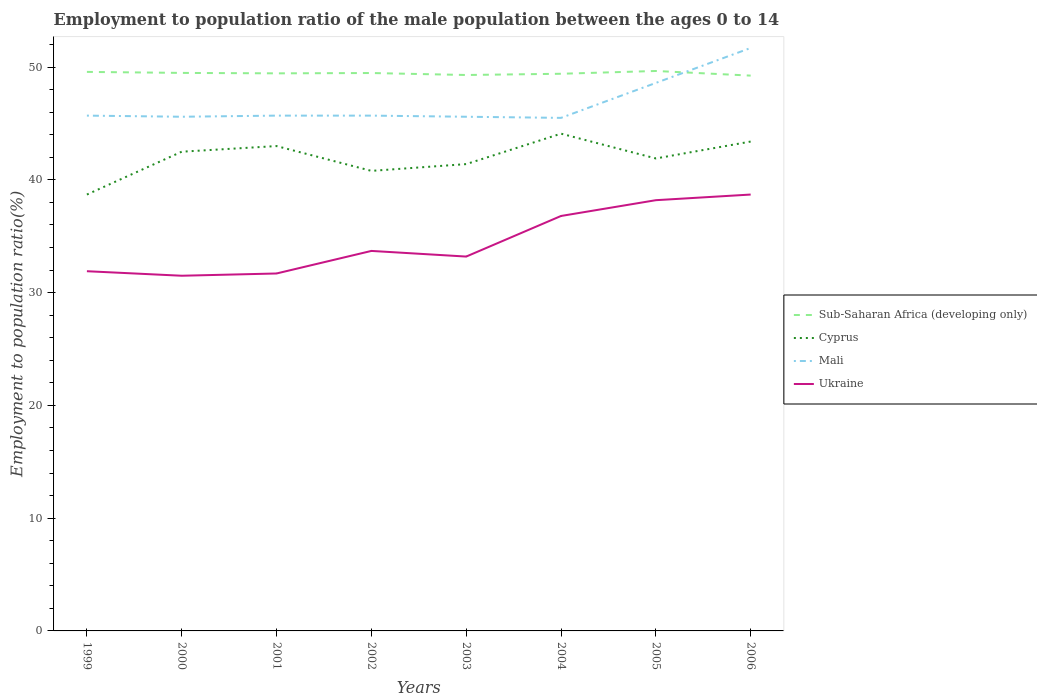Does the line corresponding to Mali intersect with the line corresponding to Cyprus?
Provide a short and direct response. No. Is the number of lines equal to the number of legend labels?
Your answer should be very brief. Yes. Across all years, what is the maximum employment to population ratio in Sub-Saharan Africa (developing only)?
Keep it short and to the point. 49.25. In which year was the employment to population ratio in Mali maximum?
Offer a very short reply. 2004. What is the difference between the highest and the second highest employment to population ratio in Ukraine?
Your response must be concise. 7.2. What is the difference between the highest and the lowest employment to population ratio in Ukraine?
Ensure brevity in your answer.  3. Is the employment to population ratio in Ukraine strictly greater than the employment to population ratio in Mali over the years?
Keep it short and to the point. Yes. Does the graph contain grids?
Keep it short and to the point. No. How are the legend labels stacked?
Offer a terse response. Vertical. What is the title of the graph?
Your response must be concise. Employment to population ratio of the male population between the ages 0 to 14. What is the label or title of the X-axis?
Provide a short and direct response. Years. What is the label or title of the Y-axis?
Offer a terse response. Employment to population ratio(%). What is the Employment to population ratio(%) of Sub-Saharan Africa (developing only) in 1999?
Your answer should be very brief. 49.58. What is the Employment to population ratio(%) in Cyprus in 1999?
Offer a very short reply. 38.7. What is the Employment to population ratio(%) of Mali in 1999?
Give a very brief answer. 45.7. What is the Employment to population ratio(%) of Ukraine in 1999?
Your response must be concise. 31.9. What is the Employment to population ratio(%) in Sub-Saharan Africa (developing only) in 2000?
Ensure brevity in your answer.  49.49. What is the Employment to population ratio(%) of Cyprus in 2000?
Your response must be concise. 42.5. What is the Employment to population ratio(%) of Mali in 2000?
Offer a terse response. 45.6. What is the Employment to population ratio(%) in Ukraine in 2000?
Make the answer very short. 31.5. What is the Employment to population ratio(%) of Sub-Saharan Africa (developing only) in 2001?
Offer a terse response. 49.45. What is the Employment to population ratio(%) of Mali in 2001?
Your response must be concise. 45.7. What is the Employment to population ratio(%) of Ukraine in 2001?
Your response must be concise. 31.7. What is the Employment to population ratio(%) in Sub-Saharan Africa (developing only) in 2002?
Your answer should be very brief. 49.48. What is the Employment to population ratio(%) in Cyprus in 2002?
Your response must be concise. 40.8. What is the Employment to population ratio(%) of Mali in 2002?
Your answer should be compact. 45.7. What is the Employment to population ratio(%) in Ukraine in 2002?
Your answer should be very brief. 33.7. What is the Employment to population ratio(%) of Sub-Saharan Africa (developing only) in 2003?
Your answer should be compact. 49.3. What is the Employment to population ratio(%) of Cyprus in 2003?
Offer a terse response. 41.4. What is the Employment to population ratio(%) of Mali in 2003?
Make the answer very short. 45.6. What is the Employment to population ratio(%) of Ukraine in 2003?
Your response must be concise. 33.2. What is the Employment to population ratio(%) of Sub-Saharan Africa (developing only) in 2004?
Make the answer very short. 49.41. What is the Employment to population ratio(%) in Cyprus in 2004?
Your response must be concise. 44.1. What is the Employment to population ratio(%) in Mali in 2004?
Your response must be concise. 45.5. What is the Employment to population ratio(%) in Ukraine in 2004?
Offer a terse response. 36.8. What is the Employment to population ratio(%) in Sub-Saharan Africa (developing only) in 2005?
Your answer should be very brief. 49.66. What is the Employment to population ratio(%) of Cyprus in 2005?
Provide a succinct answer. 41.9. What is the Employment to population ratio(%) of Mali in 2005?
Your response must be concise. 48.6. What is the Employment to population ratio(%) of Ukraine in 2005?
Your answer should be compact. 38.2. What is the Employment to population ratio(%) in Sub-Saharan Africa (developing only) in 2006?
Offer a very short reply. 49.25. What is the Employment to population ratio(%) in Cyprus in 2006?
Your response must be concise. 43.4. What is the Employment to population ratio(%) in Mali in 2006?
Keep it short and to the point. 51.7. What is the Employment to population ratio(%) of Ukraine in 2006?
Keep it short and to the point. 38.7. Across all years, what is the maximum Employment to population ratio(%) in Sub-Saharan Africa (developing only)?
Your answer should be very brief. 49.66. Across all years, what is the maximum Employment to population ratio(%) of Cyprus?
Your answer should be compact. 44.1. Across all years, what is the maximum Employment to population ratio(%) of Mali?
Provide a succinct answer. 51.7. Across all years, what is the maximum Employment to population ratio(%) of Ukraine?
Keep it short and to the point. 38.7. Across all years, what is the minimum Employment to population ratio(%) of Sub-Saharan Africa (developing only)?
Your answer should be compact. 49.25. Across all years, what is the minimum Employment to population ratio(%) of Cyprus?
Your answer should be compact. 38.7. Across all years, what is the minimum Employment to population ratio(%) of Mali?
Give a very brief answer. 45.5. Across all years, what is the minimum Employment to population ratio(%) of Ukraine?
Provide a succinct answer. 31.5. What is the total Employment to population ratio(%) of Sub-Saharan Africa (developing only) in the graph?
Make the answer very short. 395.61. What is the total Employment to population ratio(%) of Cyprus in the graph?
Give a very brief answer. 335.8. What is the total Employment to population ratio(%) of Mali in the graph?
Your answer should be very brief. 374.1. What is the total Employment to population ratio(%) in Ukraine in the graph?
Offer a terse response. 275.7. What is the difference between the Employment to population ratio(%) of Sub-Saharan Africa (developing only) in 1999 and that in 2000?
Provide a succinct answer. 0.09. What is the difference between the Employment to population ratio(%) in Ukraine in 1999 and that in 2000?
Provide a short and direct response. 0.4. What is the difference between the Employment to population ratio(%) in Sub-Saharan Africa (developing only) in 1999 and that in 2001?
Provide a short and direct response. 0.13. What is the difference between the Employment to population ratio(%) in Ukraine in 1999 and that in 2001?
Your response must be concise. 0.2. What is the difference between the Employment to population ratio(%) of Sub-Saharan Africa (developing only) in 1999 and that in 2002?
Make the answer very short. 0.1. What is the difference between the Employment to population ratio(%) in Cyprus in 1999 and that in 2002?
Keep it short and to the point. -2.1. What is the difference between the Employment to population ratio(%) of Mali in 1999 and that in 2002?
Provide a succinct answer. 0. What is the difference between the Employment to population ratio(%) of Sub-Saharan Africa (developing only) in 1999 and that in 2003?
Offer a terse response. 0.28. What is the difference between the Employment to population ratio(%) of Cyprus in 1999 and that in 2003?
Ensure brevity in your answer.  -2.7. What is the difference between the Employment to population ratio(%) in Mali in 1999 and that in 2003?
Your answer should be compact. 0.1. What is the difference between the Employment to population ratio(%) of Ukraine in 1999 and that in 2003?
Offer a very short reply. -1.3. What is the difference between the Employment to population ratio(%) of Sub-Saharan Africa (developing only) in 1999 and that in 2004?
Your answer should be compact. 0.17. What is the difference between the Employment to population ratio(%) in Ukraine in 1999 and that in 2004?
Your answer should be very brief. -4.9. What is the difference between the Employment to population ratio(%) in Sub-Saharan Africa (developing only) in 1999 and that in 2005?
Keep it short and to the point. -0.08. What is the difference between the Employment to population ratio(%) of Sub-Saharan Africa (developing only) in 1999 and that in 2006?
Your answer should be very brief. 0.33. What is the difference between the Employment to population ratio(%) in Ukraine in 1999 and that in 2006?
Keep it short and to the point. -6.8. What is the difference between the Employment to population ratio(%) in Sub-Saharan Africa (developing only) in 2000 and that in 2001?
Your answer should be compact. 0.04. What is the difference between the Employment to population ratio(%) in Cyprus in 2000 and that in 2001?
Keep it short and to the point. -0.5. What is the difference between the Employment to population ratio(%) of Mali in 2000 and that in 2001?
Ensure brevity in your answer.  -0.1. What is the difference between the Employment to population ratio(%) in Sub-Saharan Africa (developing only) in 2000 and that in 2002?
Make the answer very short. 0.01. What is the difference between the Employment to population ratio(%) in Cyprus in 2000 and that in 2002?
Provide a short and direct response. 1.7. What is the difference between the Employment to population ratio(%) of Mali in 2000 and that in 2002?
Your response must be concise. -0.1. What is the difference between the Employment to population ratio(%) of Ukraine in 2000 and that in 2002?
Provide a short and direct response. -2.2. What is the difference between the Employment to population ratio(%) in Sub-Saharan Africa (developing only) in 2000 and that in 2003?
Ensure brevity in your answer.  0.19. What is the difference between the Employment to population ratio(%) in Cyprus in 2000 and that in 2003?
Keep it short and to the point. 1.1. What is the difference between the Employment to population ratio(%) in Sub-Saharan Africa (developing only) in 2000 and that in 2004?
Offer a terse response. 0.08. What is the difference between the Employment to population ratio(%) in Ukraine in 2000 and that in 2004?
Provide a short and direct response. -5.3. What is the difference between the Employment to population ratio(%) of Sub-Saharan Africa (developing only) in 2000 and that in 2005?
Make the answer very short. -0.17. What is the difference between the Employment to population ratio(%) in Cyprus in 2000 and that in 2005?
Make the answer very short. 0.6. What is the difference between the Employment to population ratio(%) of Mali in 2000 and that in 2005?
Your answer should be compact. -3. What is the difference between the Employment to population ratio(%) of Sub-Saharan Africa (developing only) in 2000 and that in 2006?
Ensure brevity in your answer.  0.24. What is the difference between the Employment to population ratio(%) in Ukraine in 2000 and that in 2006?
Your response must be concise. -7.2. What is the difference between the Employment to population ratio(%) in Sub-Saharan Africa (developing only) in 2001 and that in 2002?
Offer a very short reply. -0.03. What is the difference between the Employment to population ratio(%) of Cyprus in 2001 and that in 2002?
Keep it short and to the point. 2.2. What is the difference between the Employment to population ratio(%) of Sub-Saharan Africa (developing only) in 2001 and that in 2003?
Ensure brevity in your answer.  0.15. What is the difference between the Employment to population ratio(%) of Ukraine in 2001 and that in 2003?
Provide a short and direct response. -1.5. What is the difference between the Employment to population ratio(%) of Sub-Saharan Africa (developing only) in 2001 and that in 2004?
Ensure brevity in your answer.  0.04. What is the difference between the Employment to population ratio(%) of Cyprus in 2001 and that in 2004?
Your answer should be very brief. -1.1. What is the difference between the Employment to population ratio(%) of Mali in 2001 and that in 2004?
Your response must be concise. 0.2. What is the difference between the Employment to population ratio(%) in Ukraine in 2001 and that in 2004?
Give a very brief answer. -5.1. What is the difference between the Employment to population ratio(%) in Sub-Saharan Africa (developing only) in 2001 and that in 2005?
Give a very brief answer. -0.21. What is the difference between the Employment to population ratio(%) in Mali in 2001 and that in 2005?
Offer a terse response. -2.9. What is the difference between the Employment to population ratio(%) of Sub-Saharan Africa (developing only) in 2001 and that in 2006?
Offer a very short reply. 0.2. What is the difference between the Employment to population ratio(%) in Cyprus in 2001 and that in 2006?
Your response must be concise. -0.4. What is the difference between the Employment to population ratio(%) of Mali in 2001 and that in 2006?
Offer a very short reply. -6. What is the difference between the Employment to population ratio(%) in Ukraine in 2001 and that in 2006?
Ensure brevity in your answer.  -7. What is the difference between the Employment to population ratio(%) of Sub-Saharan Africa (developing only) in 2002 and that in 2003?
Your response must be concise. 0.18. What is the difference between the Employment to population ratio(%) of Cyprus in 2002 and that in 2003?
Keep it short and to the point. -0.6. What is the difference between the Employment to population ratio(%) in Ukraine in 2002 and that in 2003?
Provide a succinct answer. 0.5. What is the difference between the Employment to population ratio(%) of Sub-Saharan Africa (developing only) in 2002 and that in 2004?
Provide a short and direct response. 0.07. What is the difference between the Employment to population ratio(%) in Cyprus in 2002 and that in 2004?
Offer a terse response. -3.3. What is the difference between the Employment to population ratio(%) in Mali in 2002 and that in 2004?
Your response must be concise. 0.2. What is the difference between the Employment to population ratio(%) of Sub-Saharan Africa (developing only) in 2002 and that in 2005?
Keep it short and to the point. -0.18. What is the difference between the Employment to population ratio(%) in Ukraine in 2002 and that in 2005?
Provide a succinct answer. -4.5. What is the difference between the Employment to population ratio(%) in Sub-Saharan Africa (developing only) in 2002 and that in 2006?
Your response must be concise. 0.23. What is the difference between the Employment to population ratio(%) in Mali in 2002 and that in 2006?
Your answer should be very brief. -6. What is the difference between the Employment to population ratio(%) of Sub-Saharan Africa (developing only) in 2003 and that in 2004?
Make the answer very short. -0.11. What is the difference between the Employment to population ratio(%) in Cyprus in 2003 and that in 2004?
Offer a very short reply. -2.7. What is the difference between the Employment to population ratio(%) of Sub-Saharan Africa (developing only) in 2003 and that in 2005?
Make the answer very short. -0.36. What is the difference between the Employment to population ratio(%) of Mali in 2003 and that in 2005?
Offer a very short reply. -3. What is the difference between the Employment to population ratio(%) of Ukraine in 2003 and that in 2005?
Provide a short and direct response. -5. What is the difference between the Employment to population ratio(%) in Sub-Saharan Africa (developing only) in 2003 and that in 2006?
Your answer should be compact. 0.05. What is the difference between the Employment to population ratio(%) in Cyprus in 2003 and that in 2006?
Keep it short and to the point. -2. What is the difference between the Employment to population ratio(%) in Mali in 2003 and that in 2006?
Provide a succinct answer. -6.1. What is the difference between the Employment to population ratio(%) in Sub-Saharan Africa (developing only) in 2004 and that in 2005?
Your response must be concise. -0.25. What is the difference between the Employment to population ratio(%) in Cyprus in 2004 and that in 2005?
Offer a very short reply. 2.2. What is the difference between the Employment to population ratio(%) in Sub-Saharan Africa (developing only) in 2004 and that in 2006?
Make the answer very short. 0.16. What is the difference between the Employment to population ratio(%) of Cyprus in 2004 and that in 2006?
Your response must be concise. 0.7. What is the difference between the Employment to population ratio(%) in Mali in 2004 and that in 2006?
Provide a short and direct response. -6.2. What is the difference between the Employment to population ratio(%) in Sub-Saharan Africa (developing only) in 2005 and that in 2006?
Your answer should be compact. 0.41. What is the difference between the Employment to population ratio(%) of Cyprus in 2005 and that in 2006?
Your response must be concise. -1.5. What is the difference between the Employment to population ratio(%) of Mali in 2005 and that in 2006?
Your answer should be very brief. -3.1. What is the difference between the Employment to population ratio(%) in Ukraine in 2005 and that in 2006?
Your answer should be very brief. -0.5. What is the difference between the Employment to population ratio(%) in Sub-Saharan Africa (developing only) in 1999 and the Employment to population ratio(%) in Cyprus in 2000?
Give a very brief answer. 7.08. What is the difference between the Employment to population ratio(%) of Sub-Saharan Africa (developing only) in 1999 and the Employment to population ratio(%) of Mali in 2000?
Offer a terse response. 3.98. What is the difference between the Employment to population ratio(%) of Sub-Saharan Africa (developing only) in 1999 and the Employment to population ratio(%) of Ukraine in 2000?
Your answer should be very brief. 18.08. What is the difference between the Employment to population ratio(%) of Cyprus in 1999 and the Employment to population ratio(%) of Mali in 2000?
Ensure brevity in your answer.  -6.9. What is the difference between the Employment to population ratio(%) in Mali in 1999 and the Employment to population ratio(%) in Ukraine in 2000?
Provide a succinct answer. 14.2. What is the difference between the Employment to population ratio(%) in Sub-Saharan Africa (developing only) in 1999 and the Employment to population ratio(%) in Cyprus in 2001?
Keep it short and to the point. 6.58. What is the difference between the Employment to population ratio(%) in Sub-Saharan Africa (developing only) in 1999 and the Employment to population ratio(%) in Mali in 2001?
Give a very brief answer. 3.88. What is the difference between the Employment to population ratio(%) in Sub-Saharan Africa (developing only) in 1999 and the Employment to population ratio(%) in Ukraine in 2001?
Keep it short and to the point. 17.88. What is the difference between the Employment to population ratio(%) of Cyprus in 1999 and the Employment to population ratio(%) of Mali in 2001?
Your response must be concise. -7. What is the difference between the Employment to population ratio(%) of Cyprus in 1999 and the Employment to population ratio(%) of Ukraine in 2001?
Provide a short and direct response. 7. What is the difference between the Employment to population ratio(%) of Sub-Saharan Africa (developing only) in 1999 and the Employment to population ratio(%) of Cyprus in 2002?
Give a very brief answer. 8.78. What is the difference between the Employment to population ratio(%) of Sub-Saharan Africa (developing only) in 1999 and the Employment to population ratio(%) of Mali in 2002?
Your response must be concise. 3.88. What is the difference between the Employment to population ratio(%) of Sub-Saharan Africa (developing only) in 1999 and the Employment to population ratio(%) of Ukraine in 2002?
Your response must be concise. 15.88. What is the difference between the Employment to population ratio(%) of Cyprus in 1999 and the Employment to population ratio(%) of Ukraine in 2002?
Your answer should be compact. 5. What is the difference between the Employment to population ratio(%) in Mali in 1999 and the Employment to population ratio(%) in Ukraine in 2002?
Offer a very short reply. 12. What is the difference between the Employment to population ratio(%) of Sub-Saharan Africa (developing only) in 1999 and the Employment to population ratio(%) of Cyprus in 2003?
Your answer should be compact. 8.18. What is the difference between the Employment to population ratio(%) in Sub-Saharan Africa (developing only) in 1999 and the Employment to population ratio(%) in Mali in 2003?
Your response must be concise. 3.98. What is the difference between the Employment to population ratio(%) in Sub-Saharan Africa (developing only) in 1999 and the Employment to population ratio(%) in Ukraine in 2003?
Make the answer very short. 16.38. What is the difference between the Employment to population ratio(%) of Cyprus in 1999 and the Employment to population ratio(%) of Ukraine in 2003?
Give a very brief answer. 5.5. What is the difference between the Employment to population ratio(%) in Mali in 1999 and the Employment to population ratio(%) in Ukraine in 2003?
Your response must be concise. 12.5. What is the difference between the Employment to population ratio(%) in Sub-Saharan Africa (developing only) in 1999 and the Employment to population ratio(%) in Cyprus in 2004?
Provide a short and direct response. 5.48. What is the difference between the Employment to population ratio(%) of Sub-Saharan Africa (developing only) in 1999 and the Employment to population ratio(%) of Mali in 2004?
Your answer should be very brief. 4.08. What is the difference between the Employment to population ratio(%) in Sub-Saharan Africa (developing only) in 1999 and the Employment to population ratio(%) in Ukraine in 2004?
Offer a very short reply. 12.78. What is the difference between the Employment to population ratio(%) of Sub-Saharan Africa (developing only) in 1999 and the Employment to population ratio(%) of Cyprus in 2005?
Provide a succinct answer. 7.68. What is the difference between the Employment to population ratio(%) in Sub-Saharan Africa (developing only) in 1999 and the Employment to population ratio(%) in Mali in 2005?
Offer a very short reply. 0.98. What is the difference between the Employment to population ratio(%) of Sub-Saharan Africa (developing only) in 1999 and the Employment to population ratio(%) of Ukraine in 2005?
Offer a very short reply. 11.38. What is the difference between the Employment to population ratio(%) of Mali in 1999 and the Employment to population ratio(%) of Ukraine in 2005?
Ensure brevity in your answer.  7.5. What is the difference between the Employment to population ratio(%) in Sub-Saharan Africa (developing only) in 1999 and the Employment to population ratio(%) in Cyprus in 2006?
Offer a terse response. 6.18. What is the difference between the Employment to population ratio(%) of Sub-Saharan Africa (developing only) in 1999 and the Employment to population ratio(%) of Mali in 2006?
Make the answer very short. -2.12. What is the difference between the Employment to population ratio(%) in Sub-Saharan Africa (developing only) in 1999 and the Employment to population ratio(%) in Ukraine in 2006?
Provide a short and direct response. 10.88. What is the difference between the Employment to population ratio(%) of Mali in 1999 and the Employment to population ratio(%) of Ukraine in 2006?
Your response must be concise. 7. What is the difference between the Employment to population ratio(%) in Sub-Saharan Africa (developing only) in 2000 and the Employment to population ratio(%) in Cyprus in 2001?
Give a very brief answer. 6.49. What is the difference between the Employment to population ratio(%) of Sub-Saharan Africa (developing only) in 2000 and the Employment to population ratio(%) of Mali in 2001?
Keep it short and to the point. 3.79. What is the difference between the Employment to population ratio(%) of Sub-Saharan Africa (developing only) in 2000 and the Employment to population ratio(%) of Ukraine in 2001?
Ensure brevity in your answer.  17.79. What is the difference between the Employment to population ratio(%) of Cyprus in 2000 and the Employment to population ratio(%) of Mali in 2001?
Provide a succinct answer. -3.2. What is the difference between the Employment to population ratio(%) of Cyprus in 2000 and the Employment to population ratio(%) of Ukraine in 2001?
Your response must be concise. 10.8. What is the difference between the Employment to population ratio(%) of Sub-Saharan Africa (developing only) in 2000 and the Employment to population ratio(%) of Cyprus in 2002?
Keep it short and to the point. 8.69. What is the difference between the Employment to population ratio(%) of Sub-Saharan Africa (developing only) in 2000 and the Employment to population ratio(%) of Mali in 2002?
Your response must be concise. 3.79. What is the difference between the Employment to population ratio(%) of Sub-Saharan Africa (developing only) in 2000 and the Employment to population ratio(%) of Ukraine in 2002?
Your answer should be compact. 15.79. What is the difference between the Employment to population ratio(%) in Cyprus in 2000 and the Employment to population ratio(%) in Mali in 2002?
Your response must be concise. -3.2. What is the difference between the Employment to population ratio(%) in Cyprus in 2000 and the Employment to population ratio(%) in Ukraine in 2002?
Provide a succinct answer. 8.8. What is the difference between the Employment to population ratio(%) in Sub-Saharan Africa (developing only) in 2000 and the Employment to population ratio(%) in Cyprus in 2003?
Give a very brief answer. 8.09. What is the difference between the Employment to population ratio(%) in Sub-Saharan Africa (developing only) in 2000 and the Employment to population ratio(%) in Mali in 2003?
Make the answer very short. 3.89. What is the difference between the Employment to population ratio(%) of Sub-Saharan Africa (developing only) in 2000 and the Employment to population ratio(%) of Ukraine in 2003?
Offer a terse response. 16.29. What is the difference between the Employment to population ratio(%) of Cyprus in 2000 and the Employment to population ratio(%) of Mali in 2003?
Your answer should be compact. -3.1. What is the difference between the Employment to population ratio(%) in Cyprus in 2000 and the Employment to population ratio(%) in Ukraine in 2003?
Provide a succinct answer. 9.3. What is the difference between the Employment to population ratio(%) in Mali in 2000 and the Employment to population ratio(%) in Ukraine in 2003?
Your answer should be very brief. 12.4. What is the difference between the Employment to population ratio(%) of Sub-Saharan Africa (developing only) in 2000 and the Employment to population ratio(%) of Cyprus in 2004?
Your answer should be very brief. 5.39. What is the difference between the Employment to population ratio(%) of Sub-Saharan Africa (developing only) in 2000 and the Employment to population ratio(%) of Mali in 2004?
Provide a short and direct response. 3.99. What is the difference between the Employment to population ratio(%) of Sub-Saharan Africa (developing only) in 2000 and the Employment to population ratio(%) of Ukraine in 2004?
Provide a short and direct response. 12.69. What is the difference between the Employment to population ratio(%) in Cyprus in 2000 and the Employment to population ratio(%) in Ukraine in 2004?
Your answer should be very brief. 5.7. What is the difference between the Employment to population ratio(%) in Mali in 2000 and the Employment to population ratio(%) in Ukraine in 2004?
Give a very brief answer. 8.8. What is the difference between the Employment to population ratio(%) of Sub-Saharan Africa (developing only) in 2000 and the Employment to population ratio(%) of Cyprus in 2005?
Ensure brevity in your answer.  7.59. What is the difference between the Employment to population ratio(%) in Sub-Saharan Africa (developing only) in 2000 and the Employment to population ratio(%) in Mali in 2005?
Offer a terse response. 0.89. What is the difference between the Employment to population ratio(%) of Sub-Saharan Africa (developing only) in 2000 and the Employment to population ratio(%) of Ukraine in 2005?
Offer a terse response. 11.29. What is the difference between the Employment to population ratio(%) of Sub-Saharan Africa (developing only) in 2000 and the Employment to population ratio(%) of Cyprus in 2006?
Ensure brevity in your answer.  6.09. What is the difference between the Employment to population ratio(%) of Sub-Saharan Africa (developing only) in 2000 and the Employment to population ratio(%) of Mali in 2006?
Provide a short and direct response. -2.21. What is the difference between the Employment to population ratio(%) in Sub-Saharan Africa (developing only) in 2000 and the Employment to population ratio(%) in Ukraine in 2006?
Ensure brevity in your answer.  10.79. What is the difference between the Employment to population ratio(%) in Mali in 2000 and the Employment to population ratio(%) in Ukraine in 2006?
Your answer should be very brief. 6.9. What is the difference between the Employment to population ratio(%) of Sub-Saharan Africa (developing only) in 2001 and the Employment to population ratio(%) of Cyprus in 2002?
Give a very brief answer. 8.65. What is the difference between the Employment to population ratio(%) of Sub-Saharan Africa (developing only) in 2001 and the Employment to population ratio(%) of Mali in 2002?
Offer a terse response. 3.75. What is the difference between the Employment to population ratio(%) of Sub-Saharan Africa (developing only) in 2001 and the Employment to population ratio(%) of Ukraine in 2002?
Ensure brevity in your answer.  15.75. What is the difference between the Employment to population ratio(%) in Sub-Saharan Africa (developing only) in 2001 and the Employment to population ratio(%) in Cyprus in 2003?
Make the answer very short. 8.05. What is the difference between the Employment to population ratio(%) of Sub-Saharan Africa (developing only) in 2001 and the Employment to population ratio(%) of Mali in 2003?
Keep it short and to the point. 3.85. What is the difference between the Employment to population ratio(%) of Sub-Saharan Africa (developing only) in 2001 and the Employment to population ratio(%) of Ukraine in 2003?
Give a very brief answer. 16.25. What is the difference between the Employment to population ratio(%) in Cyprus in 2001 and the Employment to population ratio(%) in Mali in 2003?
Provide a succinct answer. -2.6. What is the difference between the Employment to population ratio(%) in Sub-Saharan Africa (developing only) in 2001 and the Employment to population ratio(%) in Cyprus in 2004?
Make the answer very short. 5.35. What is the difference between the Employment to population ratio(%) of Sub-Saharan Africa (developing only) in 2001 and the Employment to population ratio(%) of Mali in 2004?
Offer a terse response. 3.95. What is the difference between the Employment to population ratio(%) in Sub-Saharan Africa (developing only) in 2001 and the Employment to population ratio(%) in Ukraine in 2004?
Your response must be concise. 12.65. What is the difference between the Employment to population ratio(%) of Cyprus in 2001 and the Employment to population ratio(%) of Ukraine in 2004?
Offer a very short reply. 6.2. What is the difference between the Employment to population ratio(%) of Sub-Saharan Africa (developing only) in 2001 and the Employment to population ratio(%) of Cyprus in 2005?
Offer a very short reply. 7.55. What is the difference between the Employment to population ratio(%) of Sub-Saharan Africa (developing only) in 2001 and the Employment to population ratio(%) of Mali in 2005?
Your answer should be very brief. 0.85. What is the difference between the Employment to population ratio(%) of Sub-Saharan Africa (developing only) in 2001 and the Employment to population ratio(%) of Ukraine in 2005?
Ensure brevity in your answer.  11.25. What is the difference between the Employment to population ratio(%) in Sub-Saharan Africa (developing only) in 2001 and the Employment to population ratio(%) in Cyprus in 2006?
Provide a succinct answer. 6.05. What is the difference between the Employment to population ratio(%) in Sub-Saharan Africa (developing only) in 2001 and the Employment to population ratio(%) in Mali in 2006?
Offer a very short reply. -2.25. What is the difference between the Employment to population ratio(%) of Sub-Saharan Africa (developing only) in 2001 and the Employment to population ratio(%) of Ukraine in 2006?
Your response must be concise. 10.75. What is the difference between the Employment to population ratio(%) in Cyprus in 2001 and the Employment to population ratio(%) in Mali in 2006?
Your answer should be very brief. -8.7. What is the difference between the Employment to population ratio(%) of Mali in 2001 and the Employment to population ratio(%) of Ukraine in 2006?
Your response must be concise. 7. What is the difference between the Employment to population ratio(%) of Sub-Saharan Africa (developing only) in 2002 and the Employment to population ratio(%) of Cyprus in 2003?
Keep it short and to the point. 8.08. What is the difference between the Employment to population ratio(%) of Sub-Saharan Africa (developing only) in 2002 and the Employment to population ratio(%) of Mali in 2003?
Ensure brevity in your answer.  3.88. What is the difference between the Employment to population ratio(%) in Sub-Saharan Africa (developing only) in 2002 and the Employment to population ratio(%) in Ukraine in 2003?
Your response must be concise. 16.28. What is the difference between the Employment to population ratio(%) of Cyprus in 2002 and the Employment to population ratio(%) of Mali in 2003?
Ensure brevity in your answer.  -4.8. What is the difference between the Employment to population ratio(%) of Mali in 2002 and the Employment to population ratio(%) of Ukraine in 2003?
Offer a terse response. 12.5. What is the difference between the Employment to population ratio(%) in Sub-Saharan Africa (developing only) in 2002 and the Employment to population ratio(%) in Cyprus in 2004?
Offer a terse response. 5.38. What is the difference between the Employment to population ratio(%) in Sub-Saharan Africa (developing only) in 2002 and the Employment to population ratio(%) in Mali in 2004?
Your answer should be very brief. 3.98. What is the difference between the Employment to population ratio(%) in Sub-Saharan Africa (developing only) in 2002 and the Employment to population ratio(%) in Ukraine in 2004?
Your response must be concise. 12.68. What is the difference between the Employment to population ratio(%) in Cyprus in 2002 and the Employment to population ratio(%) in Mali in 2004?
Provide a succinct answer. -4.7. What is the difference between the Employment to population ratio(%) of Cyprus in 2002 and the Employment to population ratio(%) of Ukraine in 2004?
Your response must be concise. 4. What is the difference between the Employment to population ratio(%) of Sub-Saharan Africa (developing only) in 2002 and the Employment to population ratio(%) of Cyprus in 2005?
Provide a short and direct response. 7.58. What is the difference between the Employment to population ratio(%) of Sub-Saharan Africa (developing only) in 2002 and the Employment to population ratio(%) of Mali in 2005?
Keep it short and to the point. 0.88. What is the difference between the Employment to population ratio(%) in Sub-Saharan Africa (developing only) in 2002 and the Employment to population ratio(%) in Ukraine in 2005?
Provide a succinct answer. 11.28. What is the difference between the Employment to population ratio(%) in Cyprus in 2002 and the Employment to population ratio(%) in Mali in 2005?
Your response must be concise. -7.8. What is the difference between the Employment to population ratio(%) in Cyprus in 2002 and the Employment to population ratio(%) in Ukraine in 2005?
Provide a short and direct response. 2.6. What is the difference between the Employment to population ratio(%) in Mali in 2002 and the Employment to population ratio(%) in Ukraine in 2005?
Provide a short and direct response. 7.5. What is the difference between the Employment to population ratio(%) of Sub-Saharan Africa (developing only) in 2002 and the Employment to population ratio(%) of Cyprus in 2006?
Your response must be concise. 6.08. What is the difference between the Employment to population ratio(%) in Sub-Saharan Africa (developing only) in 2002 and the Employment to population ratio(%) in Mali in 2006?
Make the answer very short. -2.22. What is the difference between the Employment to population ratio(%) of Sub-Saharan Africa (developing only) in 2002 and the Employment to population ratio(%) of Ukraine in 2006?
Make the answer very short. 10.78. What is the difference between the Employment to population ratio(%) in Sub-Saharan Africa (developing only) in 2003 and the Employment to population ratio(%) in Cyprus in 2004?
Offer a terse response. 5.2. What is the difference between the Employment to population ratio(%) of Sub-Saharan Africa (developing only) in 2003 and the Employment to population ratio(%) of Mali in 2004?
Offer a very short reply. 3.8. What is the difference between the Employment to population ratio(%) of Sub-Saharan Africa (developing only) in 2003 and the Employment to population ratio(%) of Ukraine in 2004?
Make the answer very short. 12.5. What is the difference between the Employment to population ratio(%) in Cyprus in 2003 and the Employment to population ratio(%) in Mali in 2004?
Provide a succinct answer. -4.1. What is the difference between the Employment to population ratio(%) in Mali in 2003 and the Employment to population ratio(%) in Ukraine in 2004?
Provide a short and direct response. 8.8. What is the difference between the Employment to population ratio(%) in Sub-Saharan Africa (developing only) in 2003 and the Employment to population ratio(%) in Cyprus in 2005?
Make the answer very short. 7.4. What is the difference between the Employment to population ratio(%) of Sub-Saharan Africa (developing only) in 2003 and the Employment to population ratio(%) of Mali in 2005?
Provide a succinct answer. 0.7. What is the difference between the Employment to population ratio(%) of Sub-Saharan Africa (developing only) in 2003 and the Employment to population ratio(%) of Ukraine in 2005?
Offer a very short reply. 11.1. What is the difference between the Employment to population ratio(%) of Cyprus in 2003 and the Employment to population ratio(%) of Ukraine in 2005?
Your answer should be compact. 3.2. What is the difference between the Employment to population ratio(%) in Sub-Saharan Africa (developing only) in 2003 and the Employment to population ratio(%) in Cyprus in 2006?
Provide a short and direct response. 5.9. What is the difference between the Employment to population ratio(%) of Sub-Saharan Africa (developing only) in 2003 and the Employment to population ratio(%) of Mali in 2006?
Ensure brevity in your answer.  -2.4. What is the difference between the Employment to population ratio(%) in Sub-Saharan Africa (developing only) in 2003 and the Employment to population ratio(%) in Ukraine in 2006?
Make the answer very short. 10.6. What is the difference between the Employment to population ratio(%) in Cyprus in 2003 and the Employment to population ratio(%) in Mali in 2006?
Ensure brevity in your answer.  -10.3. What is the difference between the Employment to population ratio(%) of Cyprus in 2003 and the Employment to population ratio(%) of Ukraine in 2006?
Your response must be concise. 2.7. What is the difference between the Employment to population ratio(%) in Mali in 2003 and the Employment to population ratio(%) in Ukraine in 2006?
Ensure brevity in your answer.  6.9. What is the difference between the Employment to population ratio(%) in Sub-Saharan Africa (developing only) in 2004 and the Employment to population ratio(%) in Cyprus in 2005?
Your answer should be very brief. 7.51. What is the difference between the Employment to population ratio(%) of Sub-Saharan Africa (developing only) in 2004 and the Employment to population ratio(%) of Mali in 2005?
Keep it short and to the point. 0.81. What is the difference between the Employment to population ratio(%) of Sub-Saharan Africa (developing only) in 2004 and the Employment to population ratio(%) of Ukraine in 2005?
Offer a very short reply. 11.21. What is the difference between the Employment to population ratio(%) of Cyprus in 2004 and the Employment to population ratio(%) of Ukraine in 2005?
Provide a succinct answer. 5.9. What is the difference between the Employment to population ratio(%) of Mali in 2004 and the Employment to population ratio(%) of Ukraine in 2005?
Provide a short and direct response. 7.3. What is the difference between the Employment to population ratio(%) of Sub-Saharan Africa (developing only) in 2004 and the Employment to population ratio(%) of Cyprus in 2006?
Provide a succinct answer. 6.01. What is the difference between the Employment to population ratio(%) of Sub-Saharan Africa (developing only) in 2004 and the Employment to population ratio(%) of Mali in 2006?
Offer a very short reply. -2.29. What is the difference between the Employment to population ratio(%) in Sub-Saharan Africa (developing only) in 2004 and the Employment to population ratio(%) in Ukraine in 2006?
Your answer should be compact. 10.71. What is the difference between the Employment to population ratio(%) of Sub-Saharan Africa (developing only) in 2005 and the Employment to population ratio(%) of Cyprus in 2006?
Offer a very short reply. 6.26. What is the difference between the Employment to population ratio(%) in Sub-Saharan Africa (developing only) in 2005 and the Employment to population ratio(%) in Mali in 2006?
Offer a terse response. -2.04. What is the difference between the Employment to population ratio(%) of Sub-Saharan Africa (developing only) in 2005 and the Employment to population ratio(%) of Ukraine in 2006?
Give a very brief answer. 10.96. What is the difference between the Employment to population ratio(%) in Cyprus in 2005 and the Employment to population ratio(%) in Mali in 2006?
Your response must be concise. -9.8. What is the average Employment to population ratio(%) in Sub-Saharan Africa (developing only) per year?
Your answer should be very brief. 49.45. What is the average Employment to population ratio(%) of Cyprus per year?
Your answer should be compact. 41.98. What is the average Employment to population ratio(%) in Mali per year?
Provide a succinct answer. 46.76. What is the average Employment to population ratio(%) of Ukraine per year?
Your answer should be very brief. 34.46. In the year 1999, what is the difference between the Employment to population ratio(%) of Sub-Saharan Africa (developing only) and Employment to population ratio(%) of Cyprus?
Your answer should be compact. 10.88. In the year 1999, what is the difference between the Employment to population ratio(%) of Sub-Saharan Africa (developing only) and Employment to population ratio(%) of Mali?
Your answer should be very brief. 3.88. In the year 1999, what is the difference between the Employment to population ratio(%) of Sub-Saharan Africa (developing only) and Employment to population ratio(%) of Ukraine?
Provide a succinct answer. 17.68. In the year 1999, what is the difference between the Employment to population ratio(%) of Cyprus and Employment to population ratio(%) of Mali?
Your response must be concise. -7. In the year 1999, what is the difference between the Employment to population ratio(%) in Cyprus and Employment to population ratio(%) in Ukraine?
Keep it short and to the point. 6.8. In the year 1999, what is the difference between the Employment to population ratio(%) in Mali and Employment to population ratio(%) in Ukraine?
Provide a short and direct response. 13.8. In the year 2000, what is the difference between the Employment to population ratio(%) of Sub-Saharan Africa (developing only) and Employment to population ratio(%) of Cyprus?
Your response must be concise. 6.99. In the year 2000, what is the difference between the Employment to population ratio(%) of Sub-Saharan Africa (developing only) and Employment to population ratio(%) of Mali?
Your answer should be very brief. 3.89. In the year 2000, what is the difference between the Employment to population ratio(%) in Sub-Saharan Africa (developing only) and Employment to population ratio(%) in Ukraine?
Give a very brief answer. 17.99. In the year 2000, what is the difference between the Employment to population ratio(%) in Mali and Employment to population ratio(%) in Ukraine?
Your answer should be compact. 14.1. In the year 2001, what is the difference between the Employment to population ratio(%) of Sub-Saharan Africa (developing only) and Employment to population ratio(%) of Cyprus?
Your response must be concise. 6.45. In the year 2001, what is the difference between the Employment to population ratio(%) of Sub-Saharan Africa (developing only) and Employment to population ratio(%) of Mali?
Offer a very short reply. 3.75. In the year 2001, what is the difference between the Employment to population ratio(%) in Sub-Saharan Africa (developing only) and Employment to population ratio(%) in Ukraine?
Make the answer very short. 17.75. In the year 2001, what is the difference between the Employment to population ratio(%) of Cyprus and Employment to population ratio(%) of Mali?
Make the answer very short. -2.7. In the year 2001, what is the difference between the Employment to population ratio(%) in Cyprus and Employment to population ratio(%) in Ukraine?
Your answer should be compact. 11.3. In the year 2002, what is the difference between the Employment to population ratio(%) in Sub-Saharan Africa (developing only) and Employment to population ratio(%) in Cyprus?
Your response must be concise. 8.68. In the year 2002, what is the difference between the Employment to population ratio(%) in Sub-Saharan Africa (developing only) and Employment to population ratio(%) in Mali?
Ensure brevity in your answer.  3.78. In the year 2002, what is the difference between the Employment to population ratio(%) of Sub-Saharan Africa (developing only) and Employment to population ratio(%) of Ukraine?
Provide a short and direct response. 15.78. In the year 2002, what is the difference between the Employment to population ratio(%) in Cyprus and Employment to population ratio(%) in Mali?
Keep it short and to the point. -4.9. In the year 2002, what is the difference between the Employment to population ratio(%) in Cyprus and Employment to population ratio(%) in Ukraine?
Provide a short and direct response. 7.1. In the year 2003, what is the difference between the Employment to population ratio(%) in Sub-Saharan Africa (developing only) and Employment to population ratio(%) in Cyprus?
Ensure brevity in your answer.  7.9. In the year 2003, what is the difference between the Employment to population ratio(%) in Sub-Saharan Africa (developing only) and Employment to population ratio(%) in Mali?
Keep it short and to the point. 3.7. In the year 2003, what is the difference between the Employment to population ratio(%) of Sub-Saharan Africa (developing only) and Employment to population ratio(%) of Ukraine?
Provide a succinct answer. 16.1. In the year 2003, what is the difference between the Employment to population ratio(%) of Cyprus and Employment to population ratio(%) of Mali?
Provide a short and direct response. -4.2. In the year 2004, what is the difference between the Employment to population ratio(%) of Sub-Saharan Africa (developing only) and Employment to population ratio(%) of Cyprus?
Give a very brief answer. 5.31. In the year 2004, what is the difference between the Employment to population ratio(%) of Sub-Saharan Africa (developing only) and Employment to population ratio(%) of Mali?
Provide a short and direct response. 3.91. In the year 2004, what is the difference between the Employment to population ratio(%) in Sub-Saharan Africa (developing only) and Employment to population ratio(%) in Ukraine?
Offer a terse response. 12.61. In the year 2005, what is the difference between the Employment to population ratio(%) of Sub-Saharan Africa (developing only) and Employment to population ratio(%) of Cyprus?
Offer a very short reply. 7.76. In the year 2005, what is the difference between the Employment to population ratio(%) of Sub-Saharan Africa (developing only) and Employment to population ratio(%) of Mali?
Give a very brief answer. 1.06. In the year 2005, what is the difference between the Employment to population ratio(%) of Sub-Saharan Africa (developing only) and Employment to population ratio(%) of Ukraine?
Offer a very short reply. 11.46. In the year 2005, what is the difference between the Employment to population ratio(%) in Cyprus and Employment to population ratio(%) in Mali?
Keep it short and to the point. -6.7. In the year 2005, what is the difference between the Employment to population ratio(%) in Cyprus and Employment to population ratio(%) in Ukraine?
Offer a terse response. 3.7. In the year 2006, what is the difference between the Employment to population ratio(%) in Sub-Saharan Africa (developing only) and Employment to population ratio(%) in Cyprus?
Your answer should be compact. 5.85. In the year 2006, what is the difference between the Employment to population ratio(%) of Sub-Saharan Africa (developing only) and Employment to population ratio(%) of Mali?
Make the answer very short. -2.45. In the year 2006, what is the difference between the Employment to population ratio(%) of Sub-Saharan Africa (developing only) and Employment to population ratio(%) of Ukraine?
Provide a succinct answer. 10.55. In the year 2006, what is the difference between the Employment to population ratio(%) of Cyprus and Employment to population ratio(%) of Mali?
Ensure brevity in your answer.  -8.3. In the year 2006, what is the difference between the Employment to population ratio(%) of Cyprus and Employment to population ratio(%) of Ukraine?
Make the answer very short. 4.7. In the year 2006, what is the difference between the Employment to population ratio(%) of Mali and Employment to population ratio(%) of Ukraine?
Make the answer very short. 13. What is the ratio of the Employment to population ratio(%) in Cyprus in 1999 to that in 2000?
Provide a succinct answer. 0.91. What is the ratio of the Employment to population ratio(%) in Ukraine in 1999 to that in 2000?
Ensure brevity in your answer.  1.01. What is the ratio of the Employment to population ratio(%) in Cyprus in 1999 to that in 2001?
Your response must be concise. 0.9. What is the ratio of the Employment to population ratio(%) of Mali in 1999 to that in 2001?
Keep it short and to the point. 1. What is the ratio of the Employment to population ratio(%) of Ukraine in 1999 to that in 2001?
Ensure brevity in your answer.  1.01. What is the ratio of the Employment to population ratio(%) in Sub-Saharan Africa (developing only) in 1999 to that in 2002?
Keep it short and to the point. 1. What is the ratio of the Employment to population ratio(%) in Cyprus in 1999 to that in 2002?
Provide a short and direct response. 0.95. What is the ratio of the Employment to population ratio(%) in Mali in 1999 to that in 2002?
Make the answer very short. 1. What is the ratio of the Employment to population ratio(%) in Ukraine in 1999 to that in 2002?
Keep it short and to the point. 0.95. What is the ratio of the Employment to population ratio(%) in Sub-Saharan Africa (developing only) in 1999 to that in 2003?
Your answer should be very brief. 1.01. What is the ratio of the Employment to population ratio(%) of Cyprus in 1999 to that in 2003?
Keep it short and to the point. 0.93. What is the ratio of the Employment to population ratio(%) of Ukraine in 1999 to that in 2003?
Offer a very short reply. 0.96. What is the ratio of the Employment to population ratio(%) of Cyprus in 1999 to that in 2004?
Provide a short and direct response. 0.88. What is the ratio of the Employment to population ratio(%) of Ukraine in 1999 to that in 2004?
Make the answer very short. 0.87. What is the ratio of the Employment to population ratio(%) in Sub-Saharan Africa (developing only) in 1999 to that in 2005?
Ensure brevity in your answer.  1. What is the ratio of the Employment to population ratio(%) of Cyprus in 1999 to that in 2005?
Make the answer very short. 0.92. What is the ratio of the Employment to population ratio(%) in Mali in 1999 to that in 2005?
Provide a succinct answer. 0.94. What is the ratio of the Employment to population ratio(%) in Ukraine in 1999 to that in 2005?
Your response must be concise. 0.84. What is the ratio of the Employment to population ratio(%) in Cyprus in 1999 to that in 2006?
Your response must be concise. 0.89. What is the ratio of the Employment to population ratio(%) in Mali in 1999 to that in 2006?
Keep it short and to the point. 0.88. What is the ratio of the Employment to population ratio(%) in Ukraine in 1999 to that in 2006?
Your answer should be very brief. 0.82. What is the ratio of the Employment to population ratio(%) of Cyprus in 2000 to that in 2001?
Your answer should be compact. 0.99. What is the ratio of the Employment to population ratio(%) in Ukraine in 2000 to that in 2001?
Offer a terse response. 0.99. What is the ratio of the Employment to population ratio(%) of Cyprus in 2000 to that in 2002?
Keep it short and to the point. 1.04. What is the ratio of the Employment to population ratio(%) in Mali in 2000 to that in 2002?
Keep it short and to the point. 1. What is the ratio of the Employment to population ratio(%) in Ukraine in 2000 to that in 2002?
Your answer should be very brief. 0.93. What is the ratio of the Employment to population ratio(%) in Sub-Saharan Africa (developing only) in 2000 to that in 2003?
Your answer should be compact. 1. What is the ratio of the Employment to population ratio(%) of Cyprus in 2000 to that in 2003?
Offer a very short reply. 1.03. What is the ratio of the Employment to population ratio(%) in Ukraine in 2000 to that in 2003?
Make the answer very short. 0.95. What is the ratio of the Employment to population ratio(%) of Sub-Saharan Africa (developing only) in 2000 to that in 2004?
Your answer should be very brief. 1. What is the ratio of the Employment to population ratio(%) in Cyprus in 2000 to that in 2004?
Your answer should be compact. 0.96. What is the ratio of the Employment to population ratio(%) of Ukraine in 2000 to that in 2004?
Your response must be concise. 0.86. What is the ratio of the Employment to population ratio(%) of Sub-Saharan Africa (developing only) in 2000 to that in 2005?
Your answer should be very brief. 1. What is the ratio of the Employment to population ratio(%) of Cyprus in 2000 to that in 2005?
Offer a terse response. 1.01. What is the ratio of the Employment to population ratio(%) in Mali in 2000 to that in 2005?
Keep it short and to the point. 0.94. What is the ratio of the Employment to population ratio(%) in Ukraine in 2000 to that in 2005?
Provide a short and direct response. 0.82. What is the ratio of the Employment to population ratio(%) of Sub-Saharan Africa (developing only) in 2000 to that in 2006?
Make the answer very short. 1. What is the ratio of the Employment to population ratio(%) of Cyprus in 2000 to that in 2006?
Provide a short and direct response. 0.98. What is the ratio of the Employment to population ratio(%) in Mali in 2000 to that in 2006?
Give a very brief answer. 0.88. What is the ratio of the Employment to population ratio(%) of Ukraine in 2000 to that in 2006?
Provide a short and direct response. 0.81. What is the ratio of the Employment to population ratio(%) in Cyprus in 2001 to that in 2002?
Your answer should be compact. 1.05. What is the ratio of the Employment to population ratio(%) of Mali in 2001 to that in 2002?
Provide a succinct answer. 1. What is the ratio of the Employment to population ratio(%) of Ukraine in 2001 to that in 2002?
Your answer should be compact. 0.94. What is the ratio of the Employment to population ratio(%) in Sub-Saharan Africa (developing only) in 2001 to that in 2003?
Your answer should be very brief. 1. What is the ratio of the Employment to population ratio(%) of Cyprus in 2001 to that in 2003?
Offer a very short reply. 1.04. What is the ratio of the Employment to population ratio(%) in Mali in 2001 to that in 2003?
Give a very brief answer. 1. What is the ratio of the Employment to population ratio(%) of Ukraine in 2001 to that in 2003?
Make the answer very short. 0.95. What is the ratio of the Employment to population ratio(%) of Cyprus in 2001 to that in 2004?
Your response must be concise. 0.98. What is the ratio of the Employment to population ratio(%) of Mali in 2001 to that in 2004?
Keep it short and to the point. 1. What is the ratio of the Employment to population ratio(%) of Ukraine in 2001 to that in 2004?
Ensure brevity in your answer.  0.86. What is the ratio of the Employment to population ratio(%) of Sub-Saharan Africa (developing only) in 2001 to that in 2005?
Make the answer very short. 1. What is the ratio of the Employment to population ratio(%) in Cyprus in 2001 to that in 2005?
Provide a succinct answer. 1.03. What is the ratio of the Employment to population ratio(%) of Mali in 2001 to that in 2005?
Offer a very short reply. 0.94. What is the ratio of the Employment to population ratio(%) of Ukraine in 2001 to that in 2005?
Give a very brief answer. 0.83. What is the ratio of the Employment to population ratio(%) of Cyprus in 2001 to that in 2006?
Offer a terse response. 0.99. What is the ratio of the Employment to population ratio(%) of Mali in 2001 to that in 2006?
Offer a very short reply. 0.88. What is the ratio of the Employment to population ratio(%) in Ukraine in 2001 to that in 2006?
Provide a short and direct response. 0.82. What is the ratio of the Employment to population ratio(%) in Cyprus in 2002 to that in 2003?
Offer a very short reply. 0.99. What is the ratio of the Employment to population ratio(%) of Mali in 2002 to that in 2003?
Provide a succinct answer. 1. What is the ratio of the Employment to population ratio(%) in Ukraine in 2002 to that in 2003?
Your answer should be very brief. 1.02. What is the ratio of the Employment to population ratio(%) of Sub-Saharan Africa (developing only) in 2002 to that in 2004?
Make the answer very short. 1. What is the ratio of the Employment to population ratio(%) in Cyprus in 2002 to that in 2004?
Make the answer very short. 0.93. What is the ratio of the Employment to population ratio(%) in Ukraine in 2002 to that in 2004?
Make the answer very short. 0.92. What is the ratio of the Employment to population ratio(%) of Cyprus in 2002 to that in 2005?
Provide a succinct answer. 0.97. What is the ratio of the Employment to population ratio(%) in Mali in 2002 to that in 2005?
Provide a short and direct response. 0.94. What is the ratio of the Employment to population ratio(%) of Ukraine in 2002 to that in 2005?
Ensure brevity in your answer.  0.88. What is the ratio of the Employment to population ratio(%) in Sub-Saharan Africa (developing only) in 2002 to that in 2006?
Provide a short and direct response. 1. What is the ratio of the Employment to population ratio(%) of Cyprus in 2002 to that in 2006?
Ensure brevity in your answer.  0.94. What is the ratio of the Employment to population ratio(%) of Mali in 2002 to that in 2006?
Your answer should be very brief. 0.88. What is the ratio of the Employment to population ratio(%) of Ukraine in 2002 to that in 2006?
Give a very brief answer. 0.87. What is the ratio of the Employment to population ratio(%) in Cyprus in 2003 to that in 2004?
Make the answer very short. 0.94. What is the ratio of the Employment to population ratio(%) of Ukraine in 2003 to that in 2004?
Give a very brief answer. 0.9. What is the ratio of the Employment to population ratio(%) in Mali in 2003 to that in 2005?
Provide a short and direct response. 0.94. What is the ratio of the Employment to population ratio(%) in Ukraine in 2003 to that in 2005?
Ensure brevity in your answer.  0.87. What is the ratio of the Employment to population ratio(%) in Sub-Saharan Africa (developing only) in 2003 to that in 2006?
Make the answer very short. 1. What is the ratio of the Employment to population ratio(%) in Cyprus in 2003 to that in 2006?
Provide a short and direct response. 0.95. What is the ratio of the Employment to population ratio(%) in Mali in 2003 to that in 2006?
Your response must be concise. 0.88. What is the ratio of the Employment to population ratio(%) of Ukraine in 2003 to that in 2006?
Provide a short and direct response. 0.86. What is the ratio of the Employment to population ratio(%) in Cyprus in 2004 to that in 2005?
Offer a very short reply. 1.05. What is the ratio of the Employment to population ratio(%) in Mali in 2004 to that in 2005?
Provide a succinct answer. 0.94. What is the ratio of the Employment to population ratio(%) of Ukraine in 2004 to that in 2005?
Your response must be concise. 0.96. What is the ratio of the Employment to population ratio(%) in Cyprus in 2004 to that in 2006?
Your response must be concise. 1.02. What is the ratio of the Employment to population ratio(%) of Mali in 2004 to that in 2006?
Provide a short and direct response. 0.88. What is the ratio of the Employment to population ratio(%) of Ukraine in 2004 to that in 2006?
Keep it short and to the point. 0.95. What is the ratio of the Employment to population ratio(%) of Sub-Saharan Africa (developing only) in 2005 to that in 2006?
Offer a very short reply. 1.01. What is the ratio of the Employment to population ratio(%) of Cyprus in 2005 to that in 2006?
Your answer should be very brief. 0.97. What is the ratio of the Employment to population ratio(%) in Ukraine in 2005 to that in 2006?
Your answer should be compact. 0.99. What is the difference between the highest and the second highest Employment to population ratio(%) of Sub-Saharan Africa (developing only)?
Your answer should be very brief. 0.08. What is the difference between the highest and the second highest Employment to population ratio(%) of Cyprus?
Offer a very short reply. 0.7. What is the difference between the highest and the second highest Employment to population ratio(%) of Mali?
Your response must be concise. 3.1. What is the difference between the highest and the second highest Employment to population ratio(%) in Ukraine?
Give a very brief answer. 0.5. What is the difference between the highest and the lowest Employment to population ratio(%) of Sub-Saharan Africa (developing only)?
Offer a very short reply. 0.41. What is the difference between the highest and the lowest Employment to population ratio(%) in Ukraine?
Ensure brevity in your answer.  7.2. 